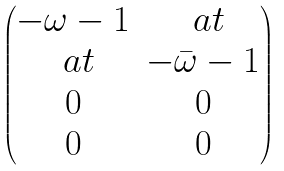<formula> <loc_0><loc_0><loc_500><loc_500>\begin{pmatrix} - \omega - 1 & \ a t \\ \ a t & - \bar { \omega } - 1 \\ 0 & 0 \\ 0 & 0 \end{pmatrix}</formula> 